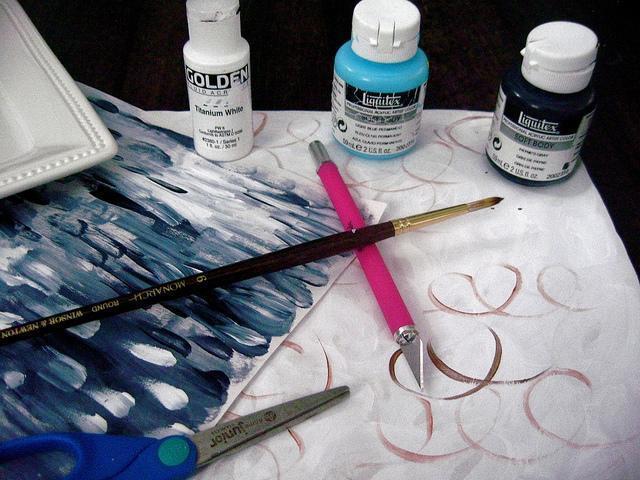How many bottles can you see?
Give a very brief answer. 3. 